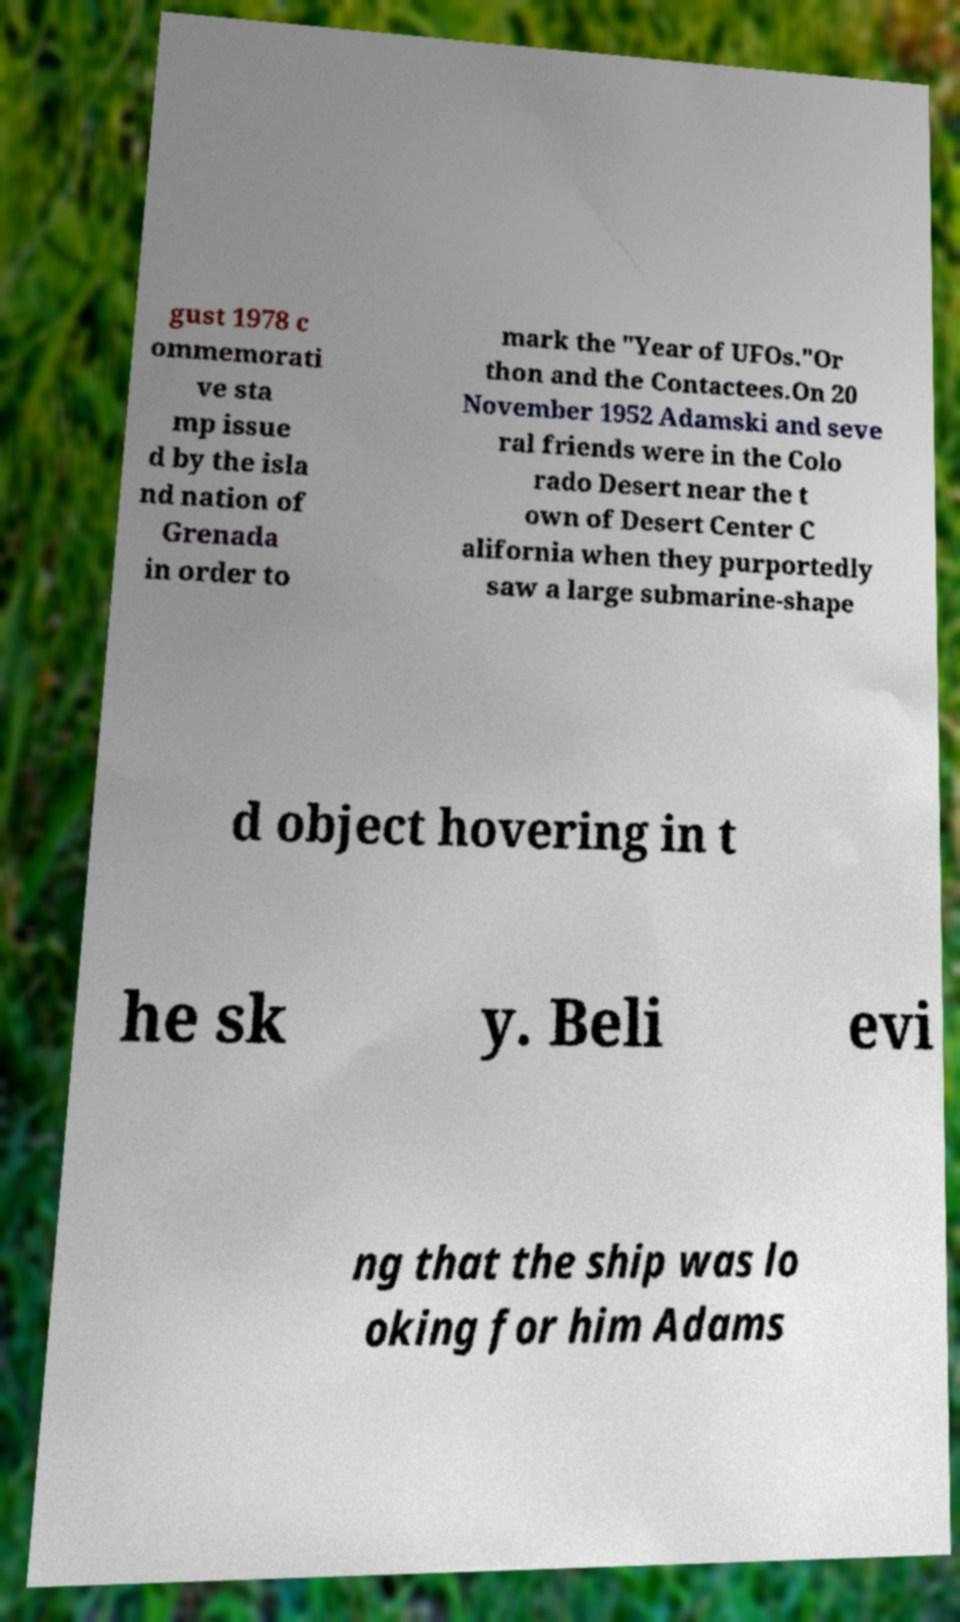Could you assist in decoding the text presented in this image and type it out clearly? gust 1978 c ommemorati ve sta mp issue d by the isla nd nation of Grenada in order to mark the "Year of UFOs."Or thon and the Contactees.On 20 November 1952 Adamski and seve ral friends were in the Colo rado Desert near the t own of Desert Center C alifornia when they purportedly saw a large submarine-shape d object hovering in t he sk y. Beli evi ng that the ship was lo oking for him Adams 